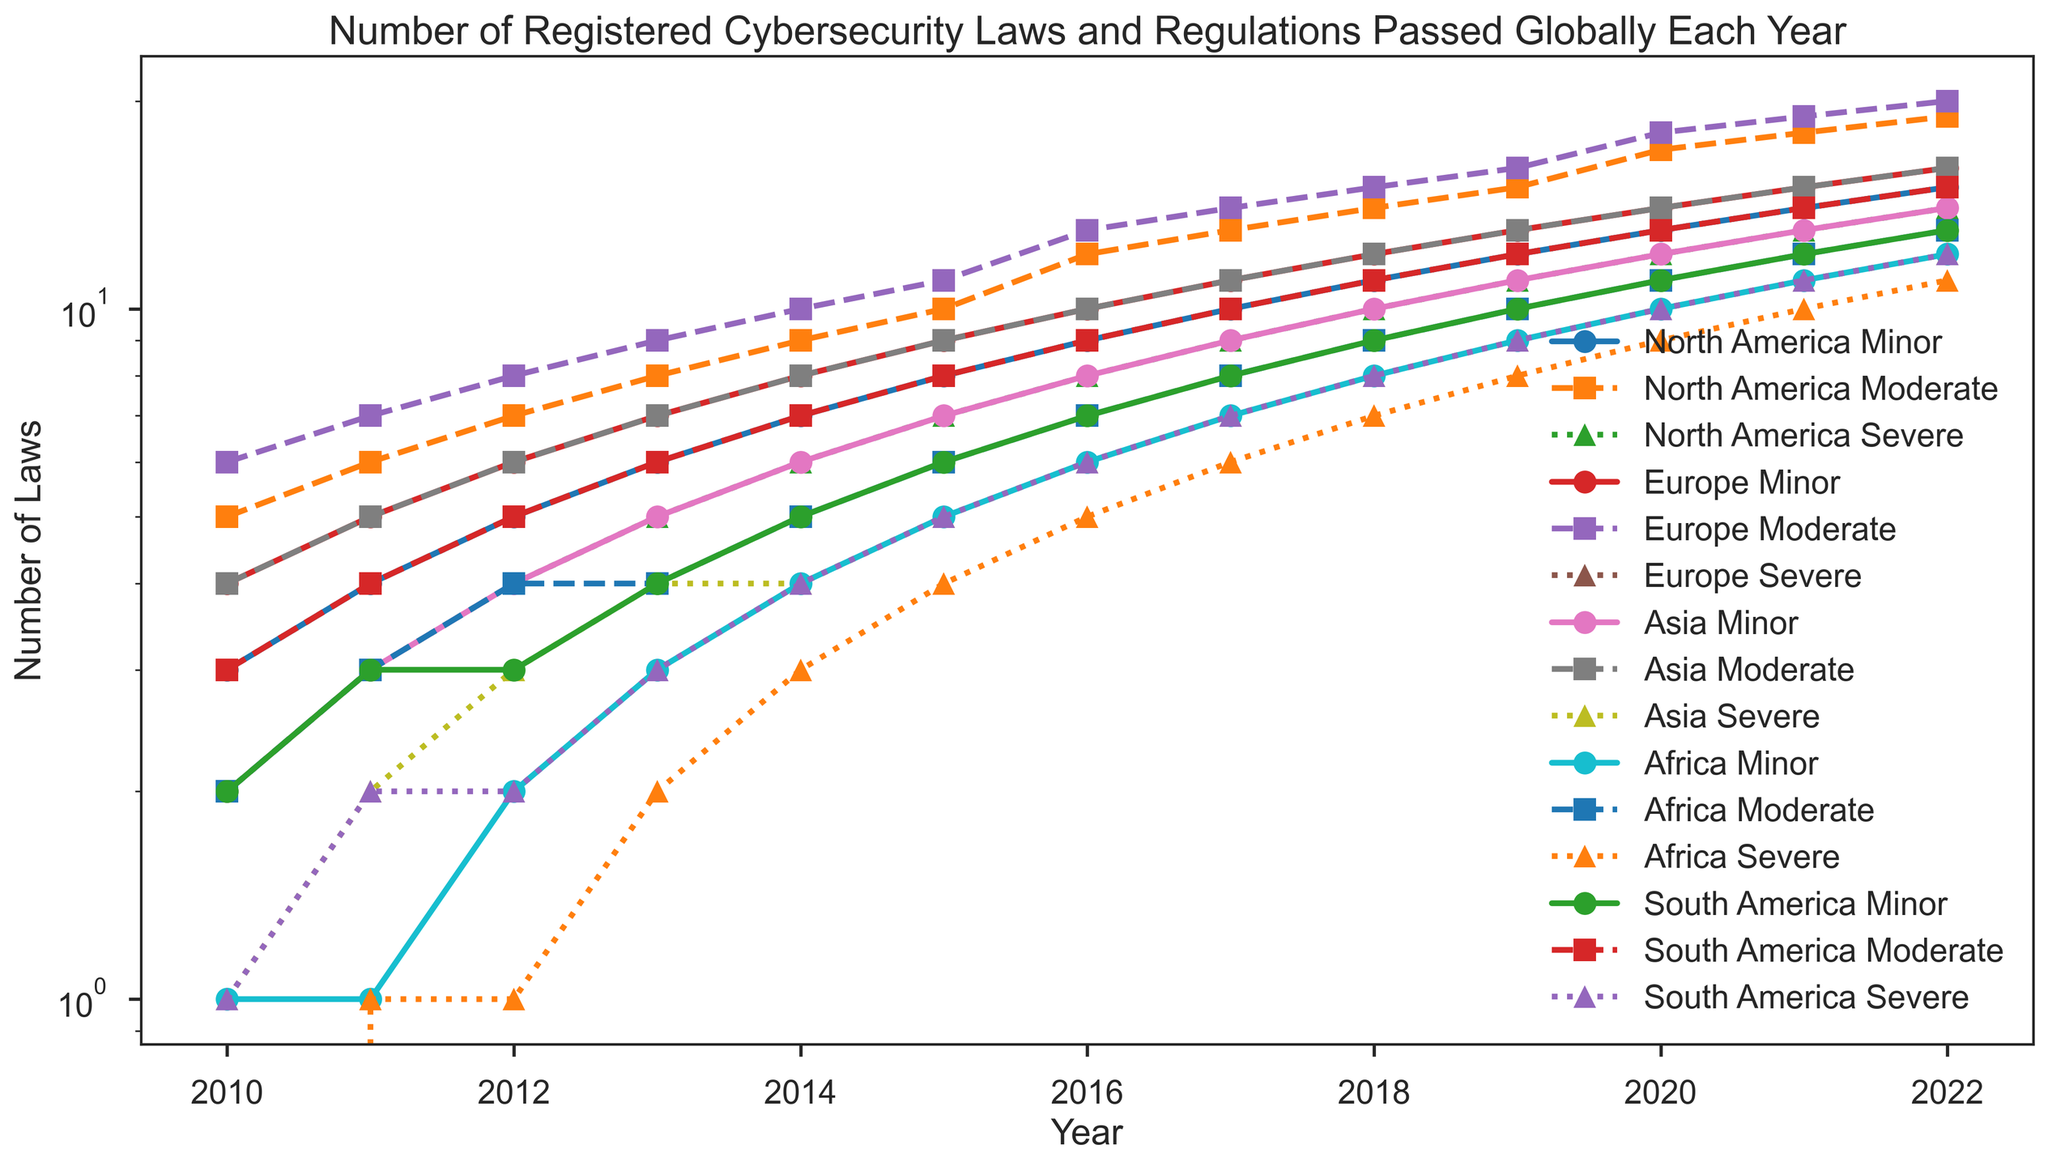What region experienced the largest increase in severe cybersecurity laws from 2010 to 2022? To determine this, check the severe category for each region in 2010 and 2022. Calculate the difference for each region. North America went from 2 to 14 (12), Europe from 3 to 15 (12), Asia from 1 to 12 (11), Africa from 0 to 11 (11), and South America from 1 to 12 (11). So both North America and Europe saw the largest increase.
Answer: North America and Europe Which region had more moderate cybersecurity laws in 2020, North America or Europe? Compare the values for moderate cybersecurity laws for North America and Europe in 2020. North America had 17 and Europe had 18.
Answer: Europe In which year did Asia surpass 10 registered moderate cybersecurity laws? Look at the plot for the moderate line in Asia and see in which year it first goes above 10. It reaches 11 in 2017.
Answer: 2017 Comparing 2013 and 2018, by how much did the number of minor cybersecurity laws in South America increase? Check the minor category for South America in 2013 and 2018. It went from 4 to 9. So the increase is 5.
Answer: 5 Which year saw the first instance of Africa having more than 5 registered cybersecurity laws in any category? Check the lines for each category in Africa. The moderate line exceeds 5 laws the first time in 2016 when it reaches 7.
Answer: 2016 What is the trend observed for severe cybersecurity laws in Europe from 2010 to 2022? Identify the points on the severe line for Europe across the years. The values consistently rise from 3 in 2010 to 15 in 2022. So, there is a clear upward trend.
Answer: Upward trend During which years did North America's minor category see exactly 10 registered laws? Check the values for the minor category line in North America. It reached 10 in 2015.
Answer: 2015 Which region had the smallest increase in severe cybersecurity laws from 2010 to 2022? Calculate the increase in severe laws for each region. North America: 12, Europe: 12, Asia: 11, Africa: 11, South America: 11. Each region experienced different levels of increases, but Africa, Asia, and South America had the smallest increase, which is 11.
Answer: Africa, Asia, and South America How many severe cybersecurity laws did Asia have in 2018 compared to Africa in the same year? Look at the values for severe laws in Asia and Africa in 2018. Asia had 8 and Africa had 7.
Answer: Asia had 8, Africa had 7 